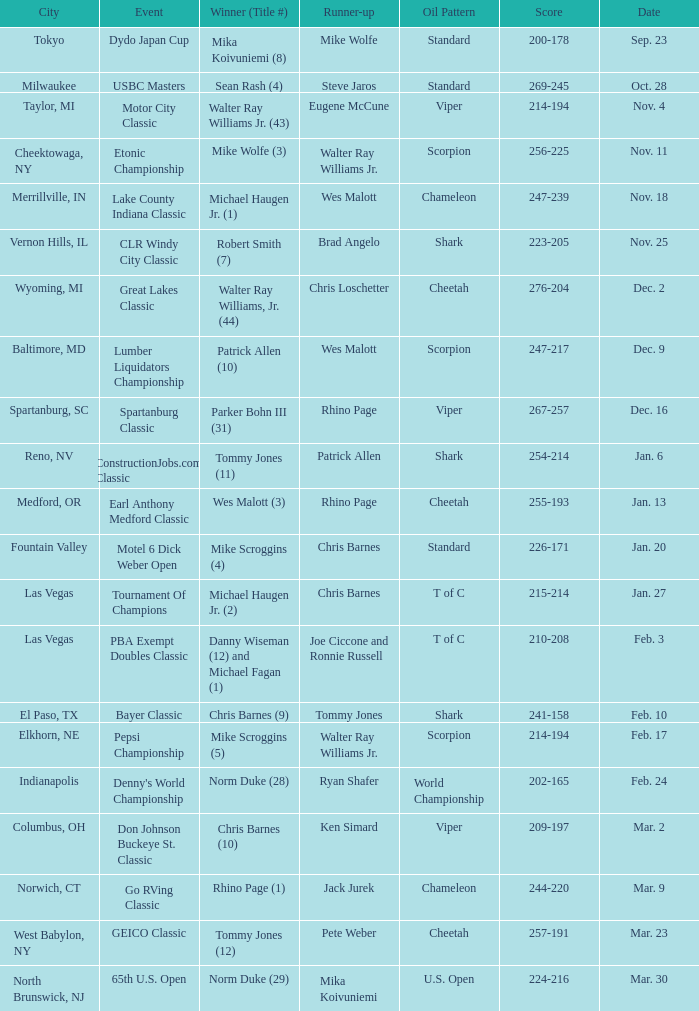Which Score has an Event of constructionjobs.com classic? 254-214. 